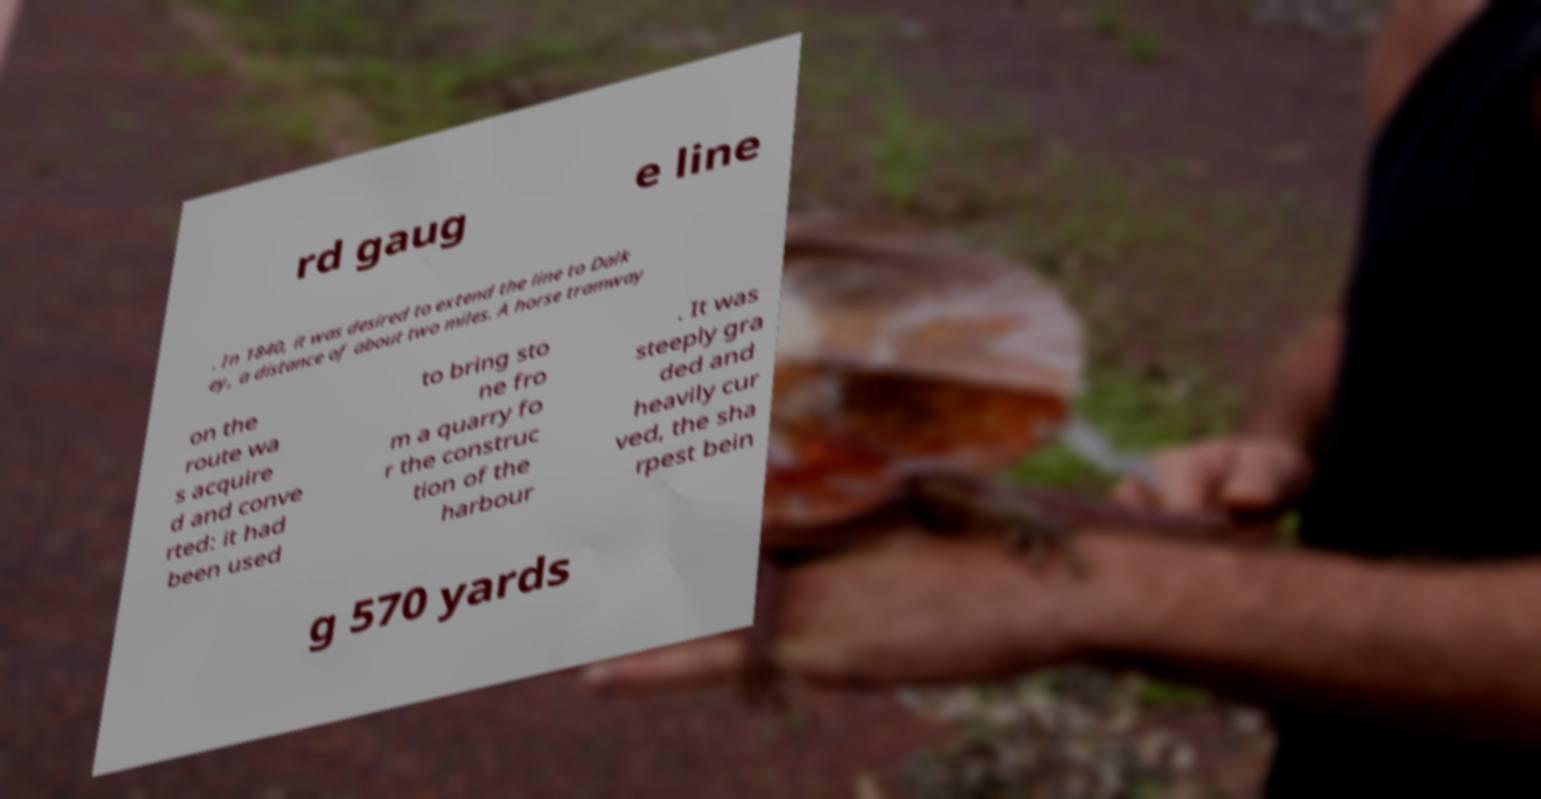There's text embedded in this image that I need extracted. Can you transcribe it verbatim? rd gaug e line . In 1840, it was desired to extend the line to Dalk ey, a distance of about two miles. A horse tramway on the route wa s acquire d and conve rted: it had been used to bring sto ne fro m a quarry fo r the construc tion of the harbour . It was steeply gra ded and heavily cur ved, the sha rpest bein g 570 yards 